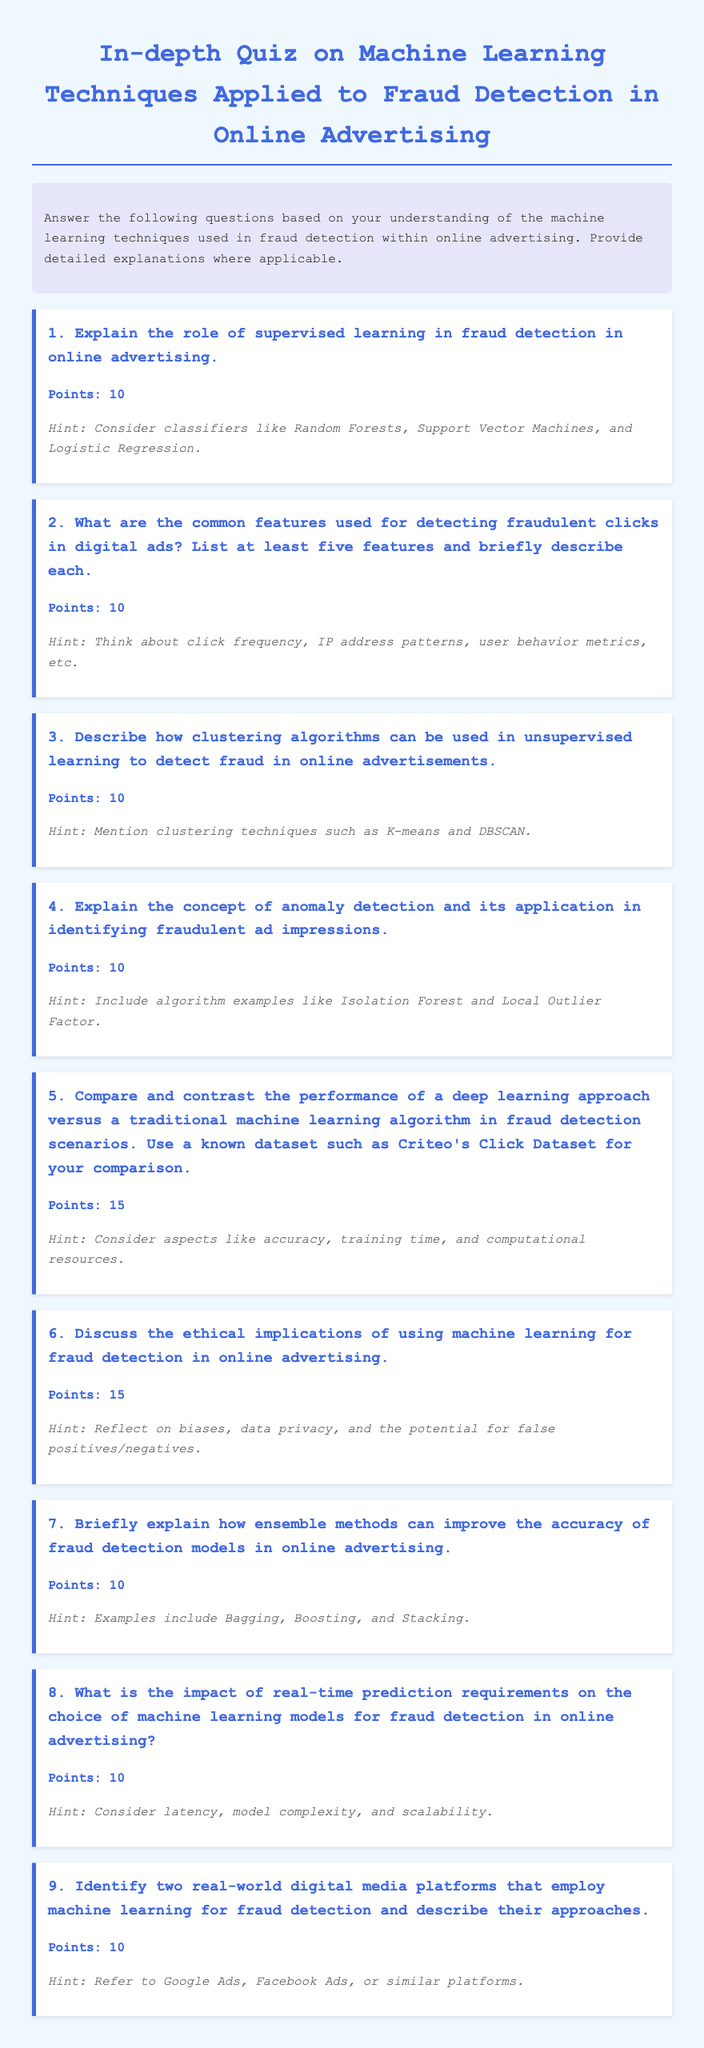What is the title of the document? The title is found in the <title> tag of the document.
Answer: In-depth Quiz on Machine Learning Techniques Applied to Fraud Detection in Online Advertising How many points is the fourth question worth? Points for questions are indicated within the document.
Answer: 10 What is the first hint provided in the document? The first hint appears under the first question in the hint section.
Answer: Consider classifiers like Random Forests, Support Vector Machines, and Logistic Regression Which clustering techniques are mentioned in the third question's hint? The clustering techniques are specified in the third question's hint section.
Answer: K-means and DBSCAN Which two algorithms are suggested in the hint for the fourth question? The algorithms are referenced in the hint for the fourth question.
Answer: Isolation Forest and Local Outlier Factor What is the focus of the quiz according to the instructions? The instructions outline the primary theme of the quiz.
Answer: Machine learning techniques used in fraud detection within online advertising How many real-world digital media platforms are to be identified in the ninth question? The ninth question explicitly states how many platforms should be identified.
Answer: Two 